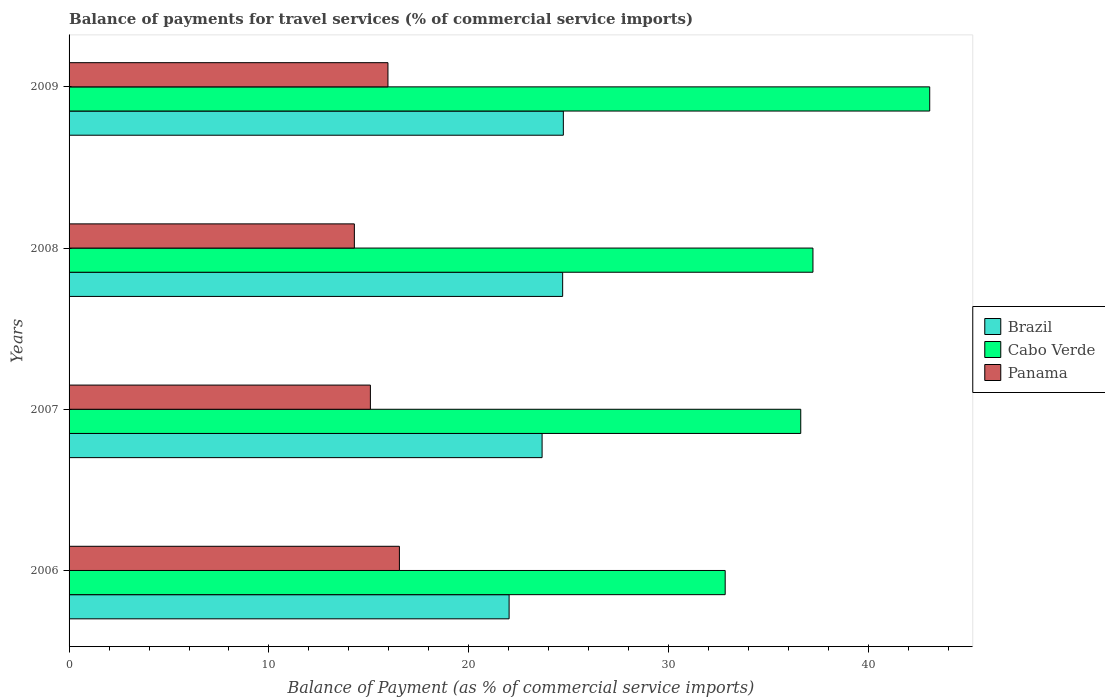How many groups of bars are there?
Provide a succinct answer. 4. Are the number of bars per tick equal to the number of legend labels?
Offer a terse response. Yes. What is the balance of payments for travel services in Brazil in 2009?
Offer a very short reply. 24.73. Across all years, what is the maximum balance of payments for travel services in Panama?
Provide a short and direct response. 16.53. Across all years, what is the minimum balance of payments for travel services in Panama?
Offer a terse response. 14.27. In which year was the balance of payments for travel services in Cabo Verde maximum?
Provide a succinct answer. 2009. What is the total balance of payments for travel services in Brazil in the graph?
Provide a succinct answer. 95.1. What is the difference between the balance of payments for travel services in Brazil in 2007 and that in 2009?
Give a very brief answer. -1.06. What is the difference between the balance of payments for travel services in Cabo Verde in 2009 and the balance of payments for travel services in Brazil in 2007?
Your response must be concise. 19.39. What is the average balance of payments for travel services in Cabo Verde per year?
Ensure brevity in your answer.  37.42. In the year 2007, what is the difference between the balance of payments for travel services in Panama and balance of payments for travel services in Brazil?
Make the answer very short. -8.59. What is the ratio of the balance of payments for travel services in Cabo Verde in 2007 to that in 2008?
Your answer should be very brief. 0.98. Is the balance of payments for travel services in Panama in 2006 less than that in 2007?
Give a very brief answer. No. Is the difference between the balance of payments for travel services in Panama in 2008 and 2009 greater than the difference between the balance of payments for travel services in Brazil in 2008 and 2009?
Offer a very short reply. No. What is the difference between the highest and the second highest balance of payments for travel services in Brazil?
Give a very brief answer. 0.03. What is the difference between the highest and the lowest balance of payments for travel services in Brazil?
Provide a succinct answer. 2.71. Is the sum of the balance of payments for travel services in Brazil in 2008 and 2009 greater than the maximum balance of payments for travel services in Panama across all years?
Offer a very short reply. Yes. What does the 2nd bar from the top in 2007 represents?
Ensure brevity in your answer.  Cabo Verde. What does the 3rd bar from the bottom in 2009 represents?
Provide a short and direct response. Panama. Is it the case that in every year, the sum of the balance of payments for travel services in Panama and balance of payments for travel services in Cabo Verde is greater than the balance of payments for travel services in Brazil?
Make the answer very short. Yes. How many bars are there?
Keep it short and to the point. 12. Are all the bars in the graph horizontal?
Keep it short and to the point. Yes. Are the values on the major ticks of X-axis written in scientific E-notation?
Provide a short and direct response. No. Does the graph contain any zero values?
Your answer should be very brief. No. Where does the legend appear in the graph?
Provide a short and direct response. Center right. How are the legend labels stacked?
Offer a terse response. Vertical. What is the title of the graph?
Your answer should be very brief. Balance of payments for travel services (% of commercial service imports). Does "Haiti" appear as one of the legend labels in the graph?
Offer a very short reply. No. What is the label or title of the X-axis?
Give a very brief answer. Balance of Payment (as % of commercial service imports). What is the label or title of the Y-axis?
Your answer should be very brief. Years. What is the Balance of Payment (as % of commercial service imports) of Brazil in 2006?
Offer a very short reply. 22.01. What is the Balance of Payment (as % of commercial service imports) of Cabo Verde in 2006?
Your response must be concise. 32.82. What is the Balance of Payment (as % of commercial service imports) in Panama in 2006?
Your answer should be very brief. 16.53. What is the Balance of Payment (as % of commercial service imports) in Brazil in 2007?
Ensure brevity in your answer.  23.66. What is the Balance of Payment (as % of commercial service imports) in Cabo Verde in 2007?
Provide a short and direct response. 36.6. What is the Balance of Payment (as % of commercial service imports) of Panama in 2007?
Your answer should be compact. 15.07. What is the Balance of Payment (as % of commercial service imports) of Brazil in 2008?
Provide a succinct answer. 24.69. What is the Balance of Payment (as % of commercial service imports) of Cabo Verde in 2008?
Your answer should be very brief. 37.21. What is the Balance of Payment (as % of commercial service imports) in Panama in 2008?
Provide a succinct answer. 14.27. What is the Balance of Payment (as % of commercial service imports) of Brazil in 2009?
Your answer should be compact. 24.73. What is the Balance of Payment (as % of commercial service imports) in Cabo Verde in 2009?
Ensure brevity in your answer.  43.06. What is the Balance of Payment (as % of commercial service imports) of Panama in 2009?
Your answer should be very brief. 15.95. Across all years, what is the maximum Balance of Payment (as % of commercial service imports) in Brazil?
Ensure brevity in your answer.  24.73. Across all years, what is the maximum Balance of Payment (as % of commercial service imports) of Cabo Verde?
Your answer should be very brief. 43.06. Across all years, what is the maximum Balance of Payment (as % of commercial service imports) in Panama?
Provide a short and direct response. 16.53. Across all years, what is the minimum Balance of Payment (as % of commercial service imports) of Brazil?
Your answer should be very brief. 22.01. Across all years, what is the minimum Balance of Payment (as % of commercial service imports) of Cabo Verde?
Offer a terse response. 32.82. Across all years, what is the minimum Balance of Payment (as % of commercial service imports) in Panama?
Keep it short and to the point. 14.27. What is the total Balance of Payment (as % of commercial service imports) in Brazil in the graph?
Your answer should be very brief. 95.1. What is the total Balance of Payment (as % of commercial service imports) of Cabo Verde in the graph?
Give a very brief answer. 149.7. What is the total Balance of Payment (as % of commercial service imports) of Panama in the graph?
Offer a terse response. 61.82. What is the difference between the Balance of Payment (as % of commercial service imports) of Brazil in 2006 and that in 2007?
Make the answer very short. -1.65. What is the difference between the Balance of Payment (as % of commercial service imports) in Cabo Verde in 2006 and that in 2007?
Provide a short and direct response. -3.78. What is the difference between the Balance of Payment (as % of commercial service imports) in Panama in 2006 and that in 2007?
Your response must be concise. 1.45. What is the difference between the Balance of Payment (as % of commercial service imports) in Brazil in 2006 and that in 2008?
Provide a short and direct response. -2.68. What is the difference between the Balance of Payment (as % of commercial service imports) in Cabo Verde in 2006 and that in 2008?
Provide a short and direct response. -4.39. What is the difference between the Balance of Payment (as % of commercial service imports) of Panama in 2006 and that in 2008?
Provide a short and direct response. 2.25. What is the difference between the Balance of Payment (as % of commercial service imports) in Brazil in 2006 and that in 2009?
Give a very brief answer. -2.71. What is the difference between the Balance of Payment (as % of commercial service imports) in Cabo Verde in 2006 and that in 2009?
Offer a very short reply. -10.23. What is the difference between the Balance of Payment (as % of commercial service imports) of Panama in 2006 and that in 2009?
Provide a succinct answer. 0.57. What is the difference between the Balance of Payment (as % of commercial service imports) in Brazil in 2007 and that in 2008?
Make the answer very short. -1.03. What is the difference between the Balance of Payment (as % of commercial service imports) in Cabo Verde in 2007 and that in 2008?
Provide a short and direct response. -0.61. What is the difference between the Balance of Payment (as % of commercial service imports) in Panama in 2007 and that in 2008?
Ensure brevity in your answer.  0.8. What is the difference between the Balance of Payment (as % of commercial service imports) in Brazil in 2007 and that in 2009?
Give a very brief answer. -1.06. What is the difference between the Balance of Payment (as % of commercial service imports) of Cabo Verde in 2007 and that in 2009?
Your answer should be compact. -6.45. What is the difference between the Balance of Payment (as % of commercial service imports) in Panama in 2007 and that in 2009?
Keep it short and to the point. -0.88. What is the difference between the Balance of Payment (as % of commercial service imports) in Brazil in 2008 and that in 2009?
Your response must be concise. -0.03. What is the difference between the Balance of Payment (as % of commercial service imports) in Cabo Verde in 2008 and that in 2009?
Your answer should be compact. -5.84. What is the difference between the Balance of Payment (as % of commercial service imports) in Panama in 2008 and that in 2009?
Ensure brevity in your answer.  -1.68. What is the difference between the Balance of Payment (as % of commercial service imports) of Brazil in 2006 and the Balance of Payment (as % of commercial service imports) of Cabo Verde in 2007?
Offer a terse response. -14.59. What is the difference between the Balance of Payment (as % of commercial service imports) in Brazil in 2006 and the Balance of Payment (as % of commercial service imports) in Panama in 2007?
Your answer should be very brief. 6.94. What is the difference between the Balance of Payment (as % of commercial service imports) in Cabo Verde in 2006 and the Balance of Payment (as % of commercial service imports) in Panama in 2007?
Ensure brevity in your answer.  17.75. What is the difference between the Balance of Payment (as % of commercial service imports) in Brazil in 2006 and the Balance of Payment (as % of commercial service imports) in Cabo Verde in 2008?
Your answer should be very brief. -15.2. What is the difference between the Balance of Payment (as % of commercial service imports) in Brazil in 2006 and the Balance of Payment (as % of commercial service imports) in Panama in 2008?
Give a very brief answer. 7.74. What is the difference between the Balance of Payment (as % of commercial service imports) of Cabo Verde in 2006 and the Balance of Payment (as % of commercial service imports) of Panama in 2008?
Offer a very short reply. 18.55. What is the difference between the Balance of Payment (as % of commercial service imports) in Brazil in 2006 and the Balance of Payment (as % of commercial service imports) in Cabo Verde in 2009?
Provide a succinct answer. -21.04. What is the difference between the Balance of Payment (as % of commercial service imports) in Brazil in 2006 and the Balance of Payment (as % of commercial service imports) in Panama in 2009?
Ensure brevity in your answer.  6.06. What is the difference between the Balance of Payment (as % of commercial service imports) of Cabo Verde in 2006 and the Balance of Payment (as % of commercial service imports) of Panama in 2009?
Your answer should be very brief. 16.87. What is the difference between the Balance of Payment (as % of commercial service imports) of Brazil in 2007 and the Balance of Payment (as % of commercial service imports) of Cabo Verde in 2008?
Provide a succinct answer. -13.55. What is the difference between the Balance of Payment (as % of commercial service imports) in Brazil in 2007 and the Balance of Payment (as % of commercial service imports) in Panama in 2008?
Offer a very short reply. 9.39. What is the difference between the Balance of Payment (as % of commercial service imports) in Cabo Verde in 2007 and the Balance of Payment (as % of commercial service imports) in Panama in 2008?
Provide a short and direct response. 22.33. What is the difference between the Balance of Payment (as % of commercial service imports) of Brazil in 2007 and the Balance of Payment (as % of commercial service imports) of Cabo Verde in 2009?
Make the answer very short. -19.39. What is the difference between the Balance of Payment (as % of commercial service imports) in Brazil in 2007 and the Balance of Payment (as % of commercial service imports) in Panama in 2009?
Provide a succinct answer. 7.71. What is the difference between the Balance of Payment (as % of commercial service imports) of Cabo Verde in 2007 and the Balance of Payment (as % of commercial service imports) of Panama in 2009?
Your answer should be compact. 20.65. What is the difference between the Balance of Payment (as % of commercial service imports) of Brazil in 2008 and the Balance of Payment (as % of commercial service imports) of Cabo Verde in 2009?
Ensure brevity in your answer.  -18.36. What is the difference between the Balance of Payment (as % of commercial service imports) of Brazil in 2008 and the Balance of Payment (as % of commercial service imports) of Panama in 2009?
Provide a short and direct response. 8.74. What is the difference between the Balance of Payment (as % of commercial service imports) in Cabo Verde in 2008 and the Balance of Payment (as % of commercial service imports) in Panama in 2009?
Your answer should be compact. 21.26. What is the average Balance of Payment (as % of commercial service imports) in Brazil per year?
Your answer should be compact. 23.77. What is the average Balance of Payment (as % of commercial service imports) in Cabo Verde per year?
Keep it short and to the point. 37.42. What is the average Balance of Payment (as % of commercial service imports) in Panama per year?
Your response must be concise. 15.46. In the year 2006, what is the difference between the Balance of Payment (as % of commercial service imports) of Brazil and Balance of Payment (as % of commercial service imports) of Cabo Verde?
Give a very brief answer. -10.81. In the year 2006, what is the difference between the Balance of Payment (as % of commercial service imports) in Brazil and Balance of Payment (as % of commercial service imports) in Panama?
Offer a very short reply. 5.49. In the year 2006, what is the difference between the Balance of Payment (as % of commercial service imports) in Cabo Verde and Balance of Payment (as % of commercial service imports) in Panama?
Give a very brief answer. 16.3. In the year 2007, what is the difference between the Balance of Payment (as % of commercial service imports) of Brazil and Balance of Payment (as % of commercial service imports) of Cabo Verde?
Your answer should be compact. -12.94. In the year 2007, what is the difference between the Balance of Payment (as % of commercial service imports) of Brazil and Balance of Payment (as % of commercial service imports) of Panama?
Ensure brevity in your answer.  8.59. In the year 2007, what is the difference between the Balance of Payment (as % of commercial service imports) in Cabo Verde and Balance of Payment (as % of commercial service imports) in Panama?
Keep it short and to the point. 21.53. In the year 2008, what is the difference between the Balance of Payment (as % of commercial service imports) of Brazil and Balance of Payment (as % of commercial service imports) of Cabo Verde?
Give a very brief answer. -12.52. In the year 2008, what is the difference between the Balance of Payment (as % of commercial service imports) in Brazil and Balance of Payment (as % of commercial service imports) in Panama?
Offer a terse response. 10.42. In the year 2008, what is the difference between the Balance of Payment (as % of commercial service imports) of Cabo Verde and Balance of Payment (as % of commercial service imports) of Panama?
Your answer should be very brief. 22.94. In the year 2009, what is the difference between the Balance of Payment (as % of commercial service imports) of Brazil and Balance of Payment (as % of commercial service imports) of Cabo Verde?
Your answer should be very brief. -18.33. In the year 2009, what is the difference between the Balance of Payment (as % of commercial service imports) of Brazil and Balance of Payment (as % of commercial service imports) of Panama?
Make the answer very short. 8.77. In the year 2009, what is the difference between the Balance of Payment (as % of commercial service imports) of Cabo Verde and Balance of Payment (as % of commercial service imports) of Panama?
Keep it short and to the point. 27.1. What is the ratio of the Balance of Payment (as % of commercial service imports) of Brazil in 2006 to that in 2007?
Provide a short and direct response. 0.93. What is the ratio of the Balance of Payment (as % of commercial service imports) of Cabo Verde in 2006 to that in 2007?
Offer a terse response. 0.9. What is the ratio of the Balance of Payment (as % of commercial service imports) in Panama in 2006 to that in 2007?
Provide a succinct answer. 1.1. What is the ratio of the Balance of Payment (as % of commercial service imports) of Brazil in 2006 to that in 2008?
Keep it short and to the point. 0.89. What is the ratio of the Balance of Payment (as % of commercial service imports) in Cabo Verde in 2006 to that in 2008?
Offer a terse response. 0.88. What is the ratio of the Balance of Payment (as % of commercial service imports) in Panama in 2006 to that in 2008?
Your answer should be compact. 1.16. What is the ratio of the Balance of Payment (as % of commercial service imports) of Brazil in 2006 to that in 2009?
Keep it short and to the point. 0.89. What is the ratio of the Balance of Payment (as % of commercial service imports) of Cabo Verde in 2006 to that in 2009?
Provide a succinct answer. 0.76. What is the ratio of the Balance of Payment (as % of commercial service imports) of Panama in 2006 to that in 2009?
Make the answer very short. 1.04. What is the ratio of the Balance of Payment (as % of commercial service imports) in Brazil in 2007 to that in 2008?
Ensure brevity in your answer.  0.96. What is the ratio of the Balance of Payment (as % of commercial service imports) of Cabo Verde in 2007 to that in 2008?
Your answer should be very brief. 0.98. What is the ratio of the Balance of Payment (as % of commercial service imports) of Panama in 2007 to that in 2008?
Provide a succinct answer. 1.06. What is the ratio of the Balance of Payment (as % of commercial service imports) in Cabo Verde in 2007 to that in 2009?
Give a very brief answer. 0.85. What is the ratio of the Balance of Payment (as % of commercial service imports) in Panama in 2007 to that in 2009?
Provide a short and direct response. 0.94. What is the ratio of the Balance of Payment (as % of commercial service imports) of Brazil in 2008 to that in 2009?
Provide a succinct answer. 1. What is the ratio of the Balance of Payment (as % of commercial service imports) in Cabo Verde in 2008 to that in 2009?
Your answer should be very brief. 0.86. What is the ratio of the Balance of Payment (as % of commercial service imports) of Panama in 2008 to that in 2009?
Keep it short and to the point. 0.89. What is the difference between the highest and the second highest Balance of Payment (as % of commercial service imports) in Brazil?
Provide a succinct answer. 0.03. What is the difference between the highest and the second highest Balance of Payment (as % of commercial service imports) of Cabo Verde?
Ensure brevity in your answer.  5.84. What is the difference between the highest and the second highest Balance of Payment (as % of commercial service imports) in Panama?
Make the answer very short. 0.57. What is the difference between the highest and the lowest Balance of Payment (as % of commercial service imports) in Brazil?
Keep it short and to the point. 2.71. What is the difference between the highest and the lowest Balance of Payment (as % of commercial service imports) in Cabo Verde?
Ensure brevity in your answer.  10.23. What is the difference between the highest and the lowest Balance of Payment (as % of commercial service imports) in Panama?
Your response must be concise. 2.25. 